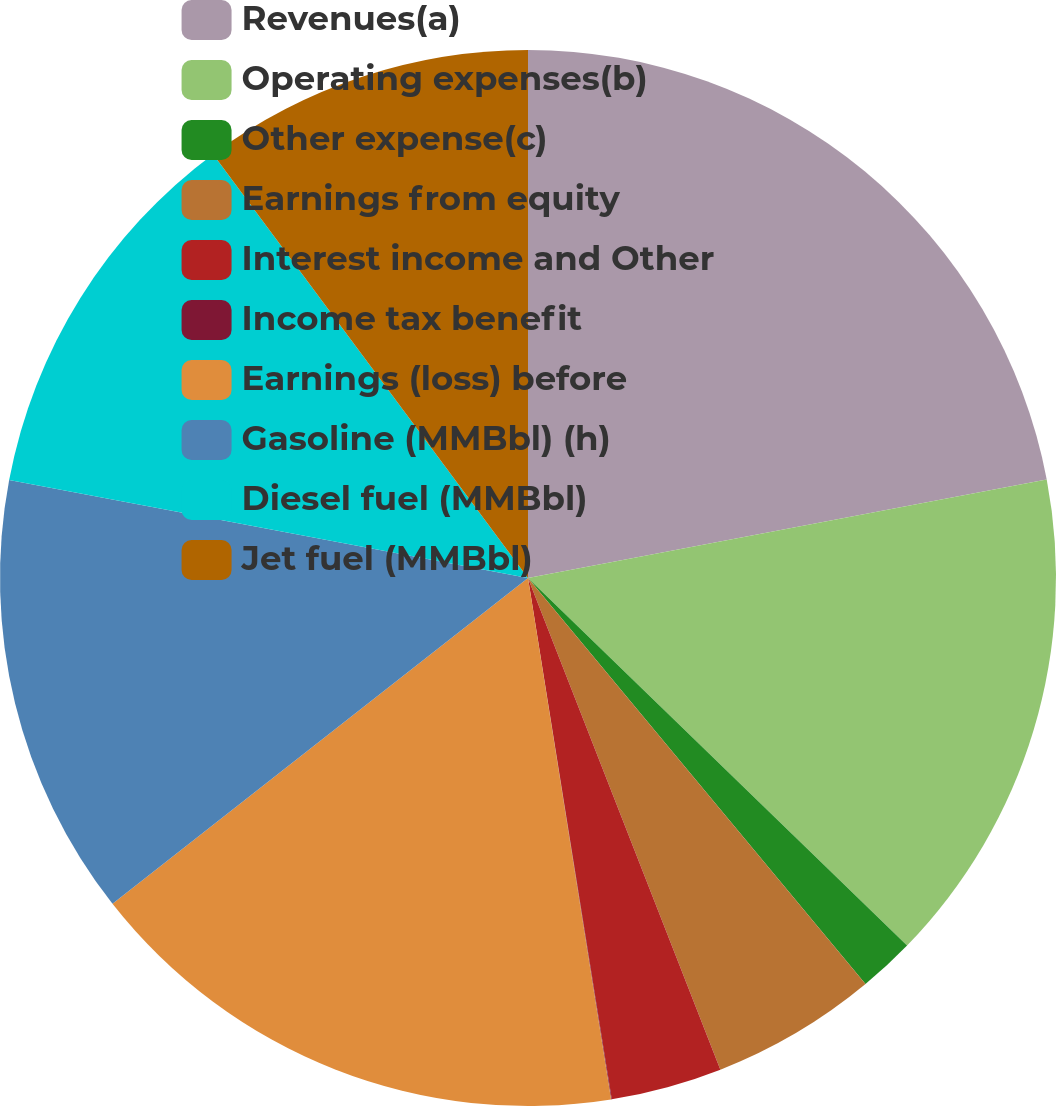Convert chart. <chart><loc_0><loc_0><loc_500><loc_500><pie_chart><fcel>Revenues(a)<fcel>Operating expenses(b)<fcel>Other expense(c)<fcel>Earnings from equity<fcel>Interest income and Other<fcel>Income tax benefit<fcel>Earnings (loss) before<fcel>Gasoline (MMBbl) (h)<fcel>Diesel fuel (MMBbl)<fcel>Jet fuel (MMBbl)<nl><fcel>22.01%<fcel>15.24%<fcel>1.71%<fcel>5.1%<fcel>3.4%<fcel>0.02%<fcel>16.93%<fcel>13.55%<fcel>11.86%<fcel>10.17%<nl></chart> 